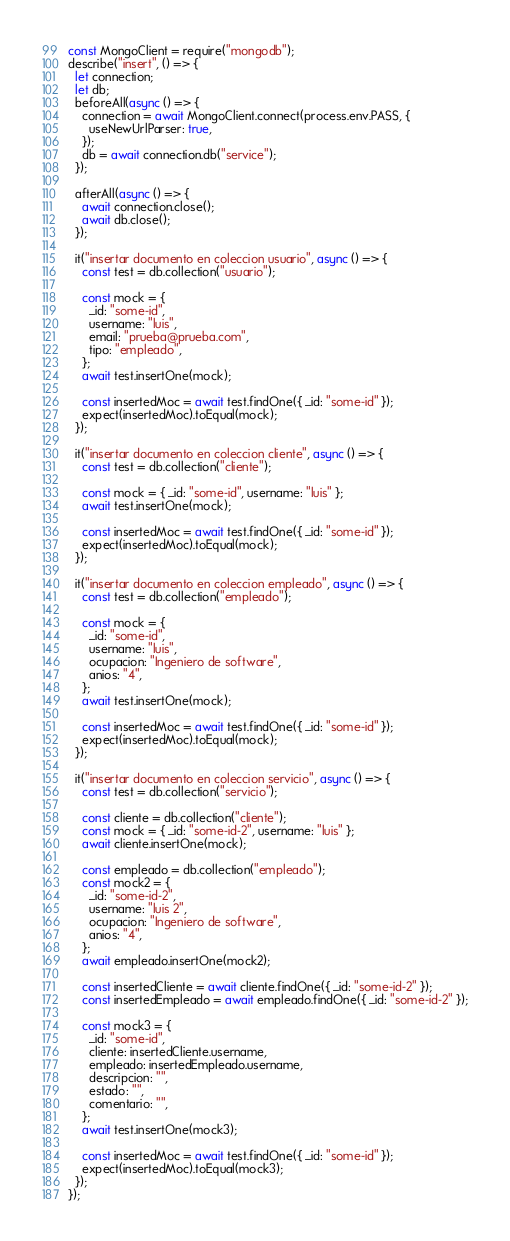<code> <loc_0><loc_0><loc_500><loc_500><_JavaScript_>const MongoClient = require("mongodb");
describe("insert", () => {
  let connection;
  let db;
  beforeAll(async () => {
    connection = await MongoClient.connect(process.env.PASS, {
      useNewUrlParser: true,
    });
    db = await connection.db("service");
  });

  afterAll(async () => {
    await connection.close();
    await db.close();
  });

  it("insertar documento en coleccion usuario", async () => {
    const test = db.collection("usuario");

    const mock = {
      _id: "some-id",
      username: "luis",
      email: "prueba@prueba.com",
      tipo: "empleado",
    };
    await test.insertOne(mock);

    const insertedMoc = await test.findOne({ _id: "some-id" });
    expect(insertedMoc).toEqual(mock);
  });

  it("insertar documento en coleccion cliente", async () => {
    const test = db.collection("cliente");

    const mock = { _id: "some-id", username: "luis" };
    await test.insertOne(mock);

    const insertedMoc = await test.findOne({ _id: "some-id" });
    expect(insertedMoc).toEqual(mock);
  });

  it("insertar documento en coleccion empleado", async () => {
    const test = db.collection("empleado");

    const mock = {
      _id: "some-id",
      username: "luis",
      ocupacion: "Ingeniero de software",
      anios: "4",
    };
    await test.insertOne(mock);

    const insertedMoc = await test.findOne({ _id: "some-id" });
    expect(insertedMoc).toEqual(mock);
  });

  it("insertar documento en coleccion servicio", async () => {
    const test = db.collection("servicio");

    const cliente = db.collection("cliente");
    const mock = { _id: "some-id-2", username: "luis" };
    await cliente.insertOne(mock);

    const empleado = db.collection("empleado");
    const mock2 = {
      _id: "some-id-2",
      username: "luis 2",
      ocupacion: "Ingeniero de software",
      anios: "4",
    };
    await empleado.insertOne(mock2);

    const insertedCliente = await cliente.findOne({ _id: "some-id-2" });
    const insertedEmpleado = await empleado.findOne({ _id: "some-id-2" });

    const mock3 = {
      _id: "some-id",
      cliente: insertedCliente.username,
      empleado: insertedEmpleado.username,
      descripcion: "",
      estado: "",
      comentario: "",
    };
    await test.insertOne(mock3);

    const insertedMoc = await test.findOne({ _id: "some-id" });
    expect(insertedMoc).toEqual(mock3);
  });
});
</code> 